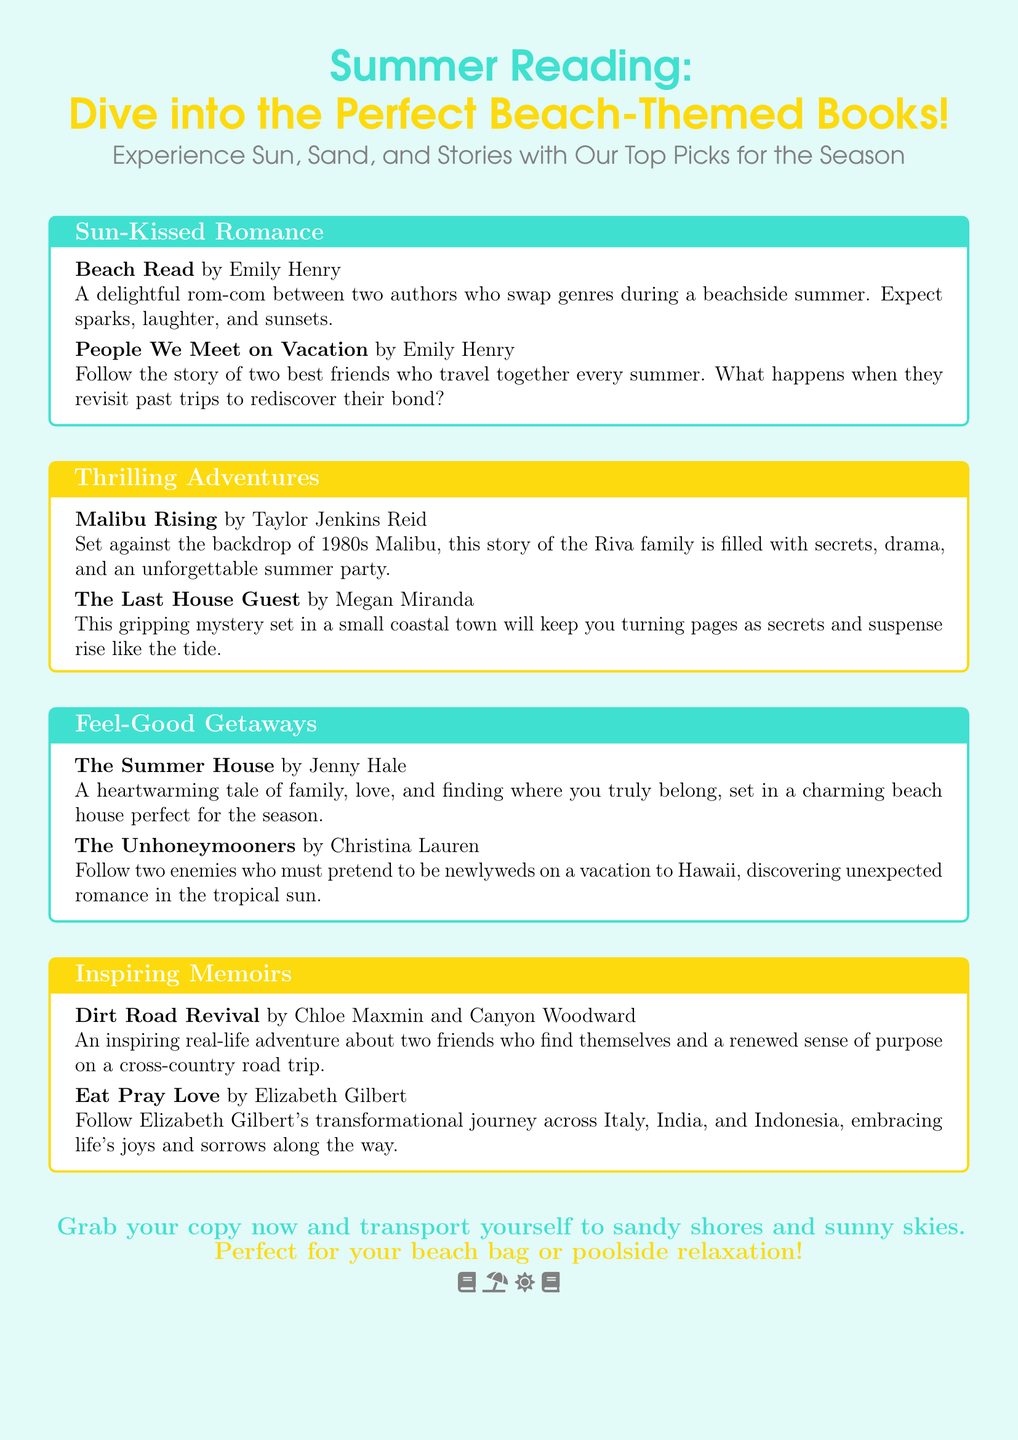What are the two titles under "Sun-Kissed Romance"? The titles listed under "Sun-Kissed Romance" are "Beach Read" and "People We Meet on Vacation".
Answer: Beach Read, People We Meet on Vacation Which author wrote "Malibu Rising"? The author of "Malibu Rising" is Taylor Jenkins Reid.
Answer: Taylor Jenkins Reid What genre does "The Last House Guest" belong to? "The Last House Guest" is categorized as a gripping mystery.
Answer: gripping mystery How many feel-good getaway titles are mentioned? There are two titles listed under "Feel-Good Getaways".
Answer: 2 Which book follows Elizabeth Gilbert's journey? The book is titled "Eat Pray Love".
Answer: Eat Pray Love What is the color scheme used for the document background? The background color scheme is a shade of summer blue.
Answer: summer blue Which theme has a title that indicates a family story? The theme "Feel-Good Getaways" has the title "The Summer House", which indicates a family story.
Answer: Feel-Good Getaways What do the closing lines suggest about the books? The closing lines suggest that the books are perfect for beach bags or poolside relaxation.
Answer: perfect for your beach bag or poolside relaxation 